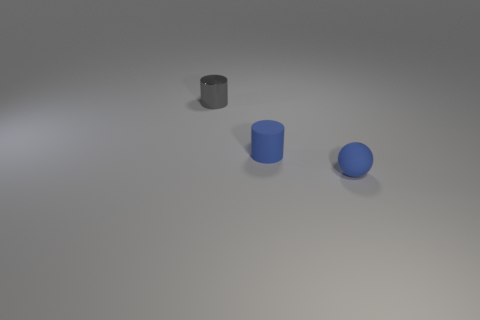There is a small blue thing that is right of the rubber cylinder; is it the same shape as the blue matte object that is behind the tiny blue matte sphere?
Keep it short and to the point. No. How many tiny cylinders are to the left of the tiny blue cylinder?
Your response must be concise. 1. What color is the cylinder in front of the small gray thing?
Keep it short and to the point. Blue. The other tiny thing that is the same shape as the metal thing is what color?
Keep it short and to the point. Blue. Is there anything else of the same color as the ball?
Keep it short and to the point. Yes. Is the number of small gray metal cylinders greater than the number of big green cubes?
Your answer should be very brief. Yes. Is the sphere made of the same material as the small blue cylinder?
Provide a succinct answer. Yes. How many cylinders have the same material as the blue ball?
Keep it short and to the point. 1. What color is the tiny object that is both behind the small ball and in front of the gray shiny thing?
Provide a short and direct response. Blue. Are there any small objects on the left side of the tiny matte object in front of the matte cylinder?
Your response must be concise. Yes. 